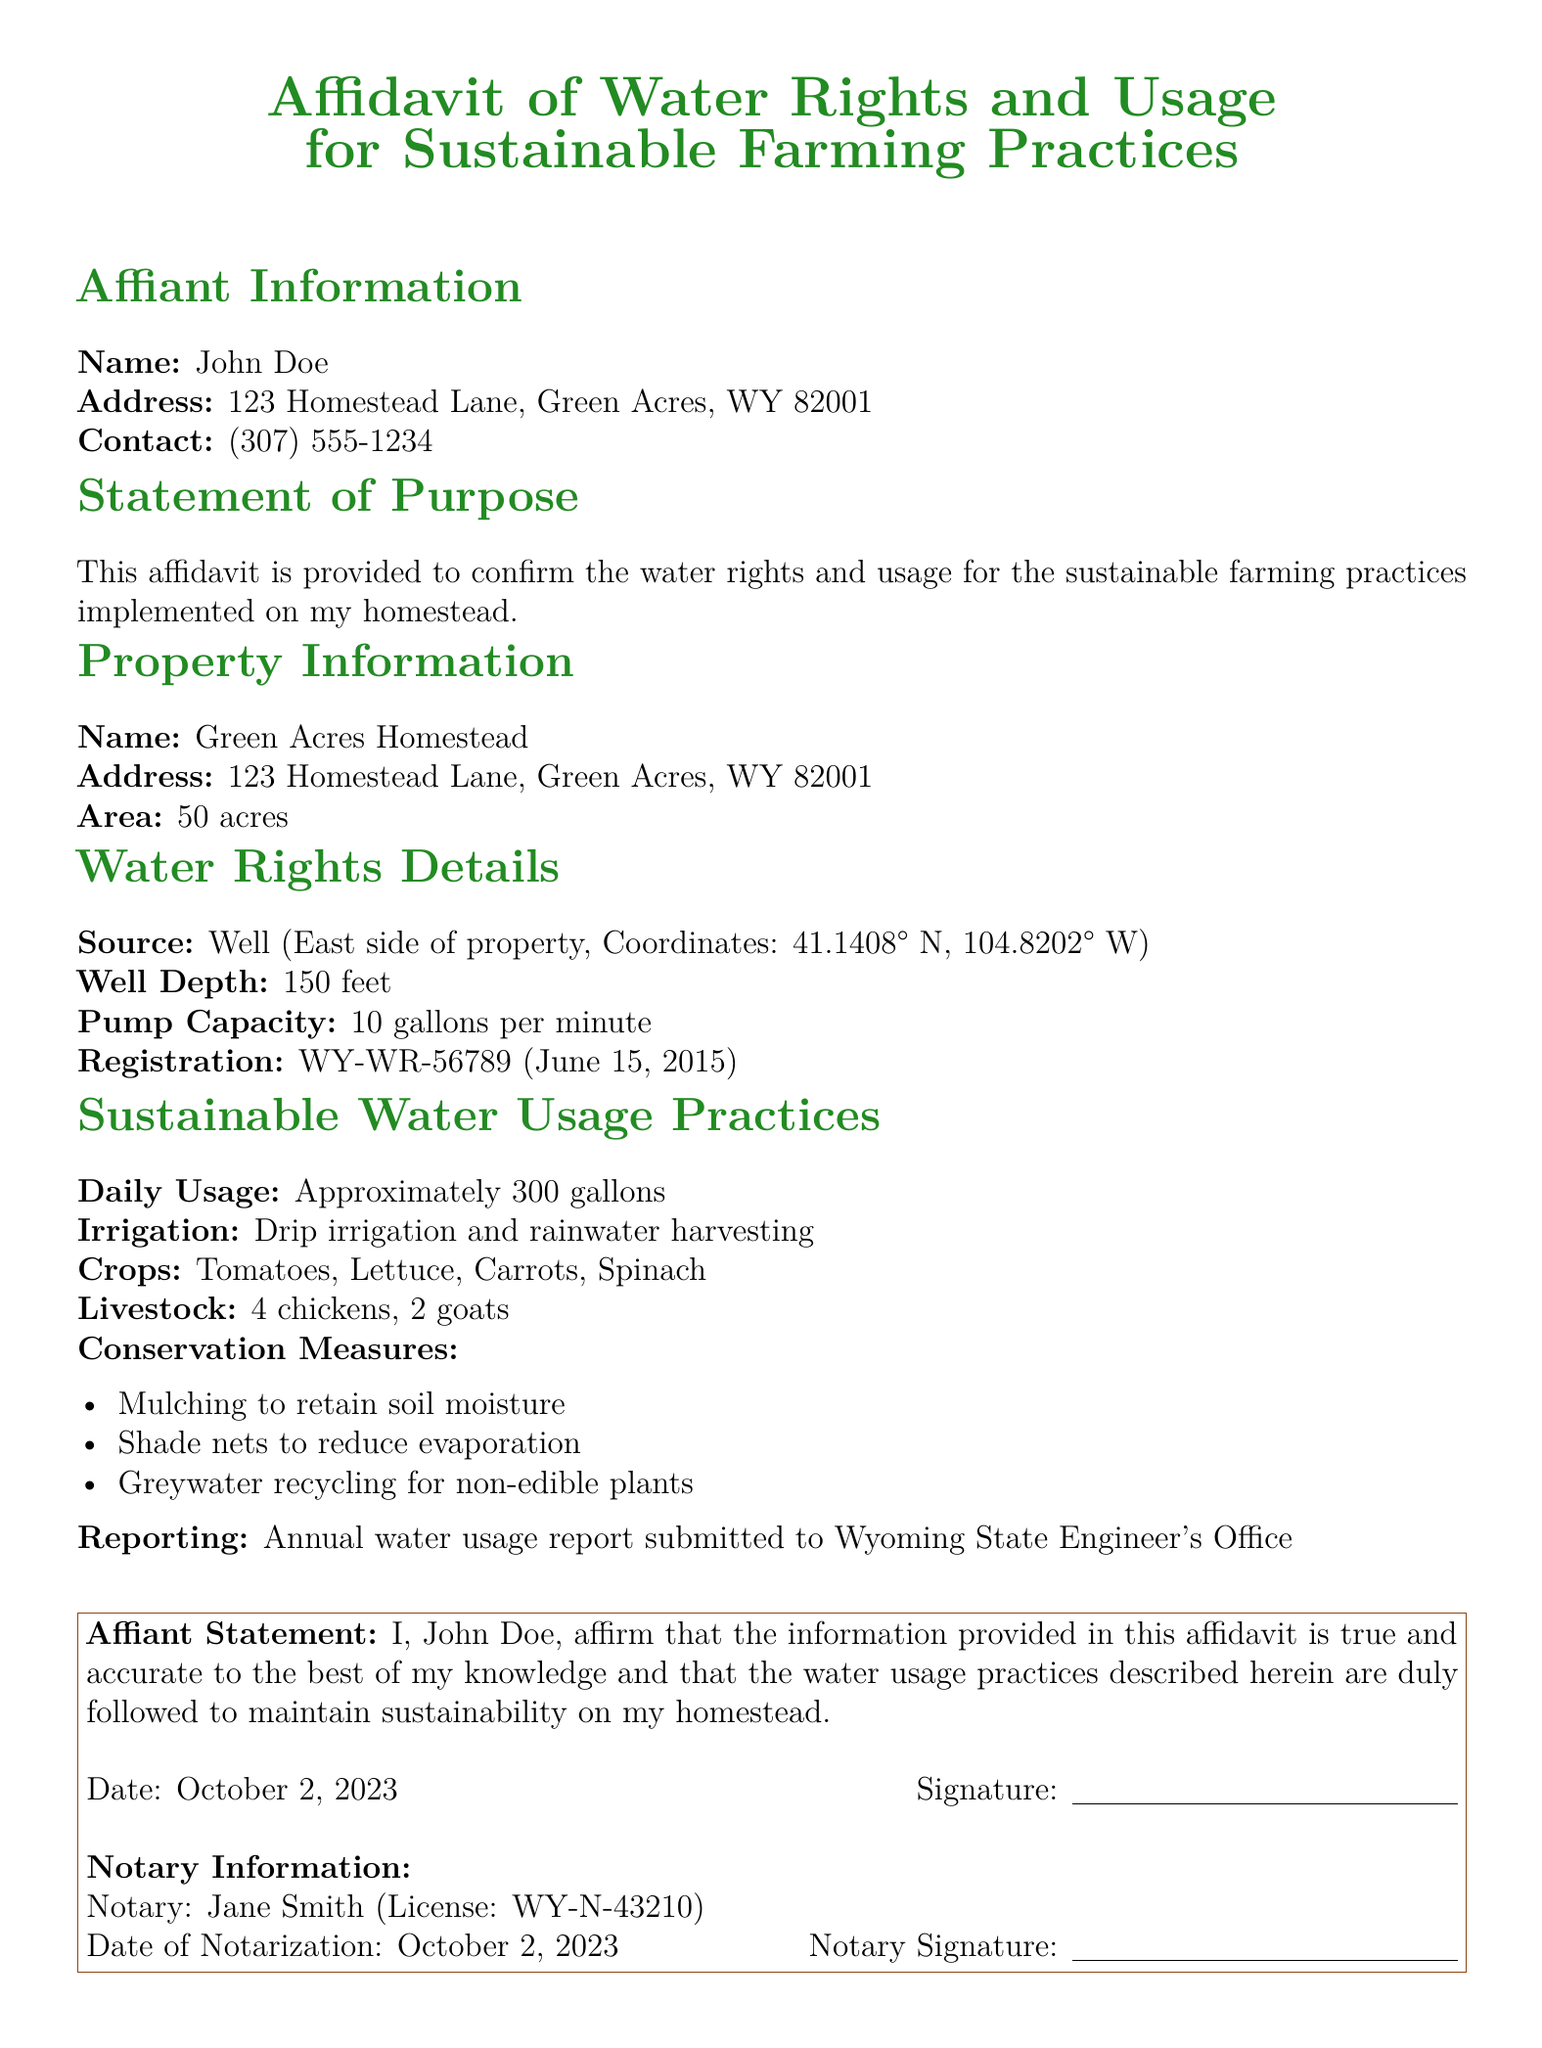What is the name of the affiant? The affiant is identified at the beginning of the document, and their name is John Doe.
Answer: John Doe What is the address of Green Acres Homestead? The document specifies the address of the property as 123 Homestead Lane, Green Acres, WY 82001.
Answer: 123 Homestead Lane, Green Acres, WY 82001 What is the depth of the well? The well's depth is mentioned in the water rights details section, which states it is 150 feet.
Answer: 150 feet How many goats are on the homestead? The livestock section lists the number of goats being two.
Answer: 2 What is the daily water usage? The daily usage is explicitly stated in the document as approximately 300 gallons.
Answer: Approximately 300 gallons What conservation measure is used to retain soil moisture? The document lists mulching as a conservation measure to retain soil moisture.
Answer: Mulching Who notarized the affidavit? The notary information section identifies Jane Smith as the notary public.
Answer: Jane Smith What is the registration number of the well? The registration number for the well is provided as WY-WR-56789.
Answer: WY-WR-56789 When was the affidavit notarized? The notary information section specifies the notarization date as October 2, 2023.
Answer: October 2, 2023 